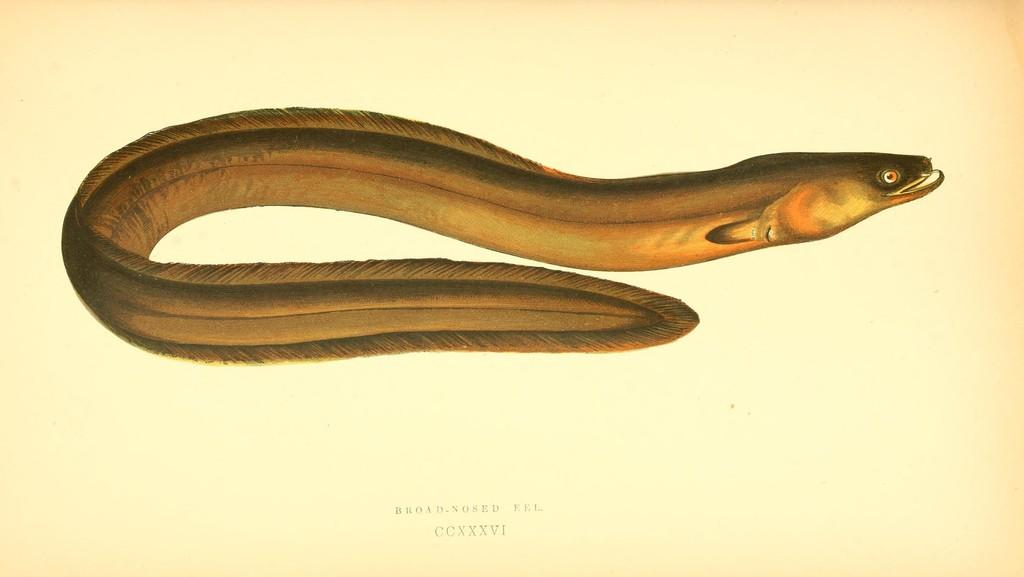What type of animal is in the image? There is a broad-nosed eel in the image. What can be found at the bottom of the image? There is text at the bottom of the image. What is the background color of the image? The background color of the image is cream. What type of furniture is depicted in the image? There is no furniture present in the image; it features a broad-nosed eel and text on a cream background. 